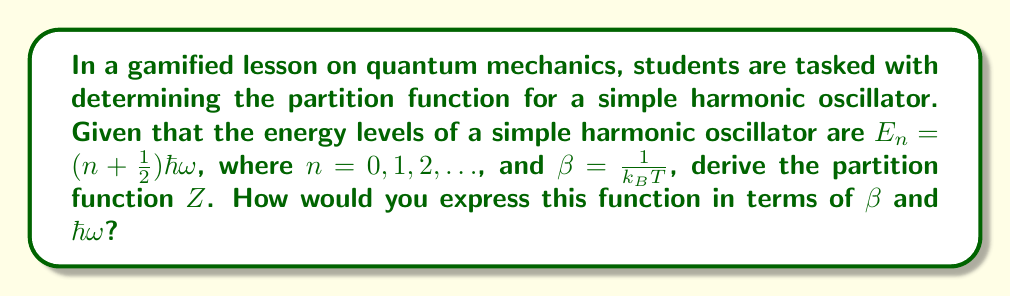Solve this math problem. To determine the partition function for a simple harmonic oscillator, we follow these steps:

1) The partition function is defined as the sum over all possible states:

   $$Z = \sum_{n=0}^{\infty} e^{-\beta E_n}$$

2) Substitute the energy levels $E_n = (n + \frac{1}{2})\hbar\omega$ into the equation:

   $$Z = \sum_{n=0}^{\infty} e^{-\beta(n + \frac{1}{2})\hbar\omega}$$

3) Factor out the constant term:

   $$Z = e^{-\frac{1}{2}\beta\hbar\omega} \sum_{n=0}^{\infty} e^{-n\beta\hbar\omega}$$

4) Recognize that the sum is a geometric series with $r = e^{-\beta\hbar\omega}$:

   $$Z = e^{-\frac{1}{2}\beta\hbar\omega} \sum_{n=0}^{\infty} (e^{-\beta\hbar\omega})^n$$

5) Use the formula for the sum of an infinite geometric series ($\sum_{n=0}^{\infty} r^n = \frac{1}{1-r}$ for $|r| < 1$):

   $$Z = e^{-\frac{1}{2}\beta\hbar\omega} \frac{1}{1 - e^{-\beta\hbar\omega}}$$

6) Simplify by finding a common denominator:

   $$Z = \frac{e^{-\frac{1}{2}\beta\hbar\omega}}{1 - e^{-\beta\hbar\omega}}$$

This is the partition function for a simple harmonic oscillator in terms of $\beta$ and $\hbar\omega$.
Answer: $$Z = \frac{e^{-\frac{1}{2}\beta\hbar\omega}}{1 - e^{-\beta\hbar\omega}}$$ 